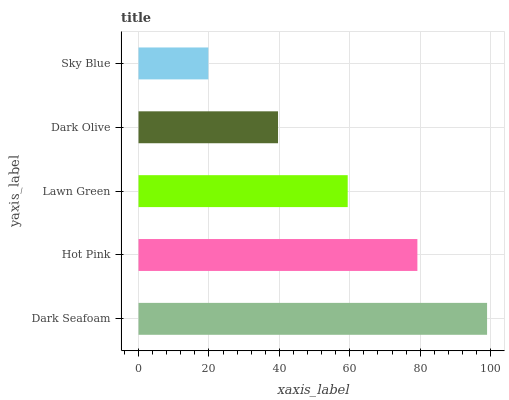Is Sky Blue the minimum?
Answer yes or no. Yes. Is Dark Seafoam the maximum?
Answer yes or no. Yes. Is Hot Pink the minimum?
Answer yes or no. No. Is Hot Pink the maximum?
Answer yes or no. No. Is Dark Seafoam greater than Hot Pink?
Answer yes or no. Yes. Is Hot Pink less than Dark Seafoam?
Answer yes or no. Yes. Is Hot Pink greater than Dark Seafoam?
Answer yes or no. No. Is Dark Seafoam less than Hot Pink?
Answer yes or no. No. Is Lawn Green the high median?
Answer yes or no. Yes. Is Lawn Green the low median?
Answer yes or no. Yes. Is Dark Seafoam the high median?
Answer yes or no. No. Is Sky Blue the low median?
Answer yes or no. No. 